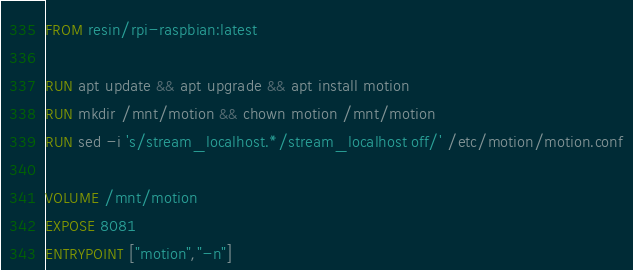Convert code to text. <code><loc_0><loc_0><loc_500><loc_500><_Dockerfile_>FROM resin/rpi-raspbian:latest

RUN apt update && apt upgrade && apt install motion
RUN mkdir /mnt/motion && chown motion /mnt/motion
RUN sed -i 's/stream_localhost.*/stream_localhost off/' /etc/motion/motion.conf

VOLUME /mnt/motion
EXPOSE 8081
ENTRYPOINT ["motion","-n"]
</code> 